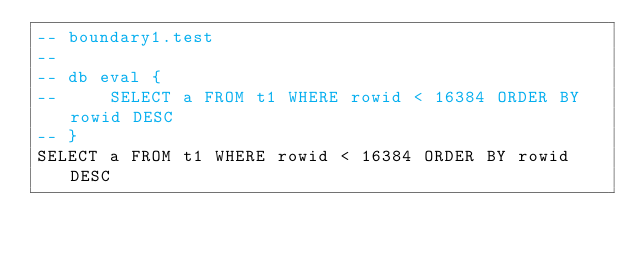<code> <loc_0><loc_0><loc_500><loc_500><_SQL_>-- boundary1.test
-- 
-- db eval {
--     SELECT a FROM t1 WHERE rowid < 16384 ORDER BY rowid DESC
-- }
SELECT a FROM t1 WHERE rowid < 16384 ORDER BY rowid DESC</code> 